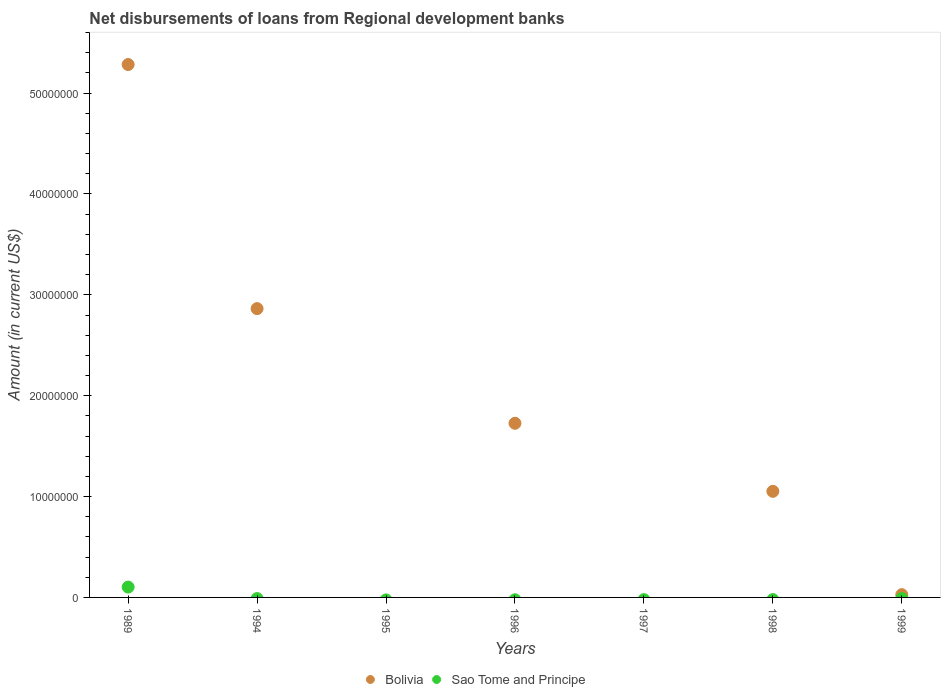How many different coloured dotlines are there?
Make the answer very short. 2. What is the amount of disbursements of loans from regional development banks in Bolivia in 1999?
Ensure brevity in your answer.  2.72e+05. Across all years, what is the maximum amount of disbursements of loans from regional development banks in Sao Tome and Principe?
Offer a terse response. 1.03e+06. Across all years, what is the minimum amount of disbursements of loans from regional development banks in Sao Tome and Principe?
Keep it short and to the point. 0. What is the total amount of disbursements of loans from regional development banks in Sao Tome and Principe in the graph?
Provide a succinct answer. 1.03e+06. What is the difference between the amount of disbursements of loans from regional development banks in Bolivia in 1996 and that in 1998?
Your answer should be compact. 6.75e+06. What is the difference between the amount of disbursements of loans from regional development banks in Bolivia in 1998 and the amount of disbursements of loans from regional development banks in Sao Tome and Principe in 1989?
Ensure brevity in your answer.  9.49e+06. What is the average amount of disbursements of loans from regional development banks in Bolivia per year?
Your response must be concise. 1.56e+07. In the year 1989, what is the difference between the amount of disbursements of loans from regional development banks in Bolivia and amount of disbursements of loans from regional development banks in Sao Tome and Principe?
Offer a terse response. 5.18e+07. What is the ratio of the amount of disbursements of loans from regional development banks in Bolivia in 1996 to that in 1998?
Offer a very short reply. 1.64. Is the amount of disbursements of loans from regional development banks in Bolivia in 1994 less than that in 1998?
Make the answer very short. No. What is the difference between the highest and the second highest amount of disbursements of loans from regional development banks in Bolivia?
Ensure brevity in your answer.  2.42e+07. What is the difference between the highest and the lowest amount of disbursements of loans from regional development banks in Sao Tome and Principe?
Your answer should be very brief. 1.03e+06. Is the sum of the amount of disbursements of loans from regional development banks in Bolivia in 1994 and 1996 greater than the maximum amount of disbursements of loans from regional development banks in Sao Tome and Principe across all years?
Make the answer very short. Yes. Does the amount of disbursements of loans from regional development banks in Bolivia monotonically increase over the years?
Your answer should be very brief. No. Is the amount of disbursements of loans from regional development banks in Sao Tome and Principe strictly less than the amount of disbursements of loans from regional development banks in Bolivia over the years?
Offer a terse response. No. How many dotlines are there?
Make the answer very short. 2. How many years are there in the graph?
Keep it short and to the point. 7. Are the values on the major ticks of Y-axis written in scientific E-notation?
Make the answer very short. No. Does the graph contain any zero values?
Your answer should be compact. Yes. Does the graph contain grids?
Keep it short and to the point. No. Where does the legend appear in the graph?
Ensure brevity in your answer.  Bottom center. How are the legend labels stacked?
Your answer should be very brief. Horizontal. What is the title of the graph?
Your response must be concise. Net disbursements of loans from Regional development banks. Does "Mexico" appear as one of the legend labels in the graph?
Give a very brief answer. No. What is the label or title of the X-axis?
Your response must be concise. Years. What is the label or title of the Y-axis?
Provide a succinct answer. Amount (in current US$). What is the Amount (in current US$) of Bolivia in 1989?
Your answer should be very brief. 5.28e+07. What is the Amount (in current US$) in Sao Tome and Principe in 1989?
Keep it short and to the point. 1.03e+06. What is the Amount (in current US$) in Bolivia in 1994?
Make the answer very short. 2.86e+07. What is the Amount (in current US$) in Bolivia in 1995?
Provide a succinct answer. 0. What is the Amount (in current US$) in Sao Tome and Principe in 1995?
Offer a very short reply. 0. What is the Amount (in current US$) of Bolivia in 1996?
Keep it short and to the point. 1.73e+07. What is the Amount (in current US$) of Sao Tome and Principe in 1996?
Offer a very short reply. 0. What is the Amount (in current US$) in Bolivia in 1997?
Make the answer very short. 0. What is the Amount (in current US$) of Sao Tome and Principe in 1997?
Your answer should be very brief. 0. What is the Amount (in current US$) of Bolivia in 1998?
Give a very brief answer. 1.05e+07. What is the Amount (in current US$) in Sao Tome and Principe in 1998?
Your answer should be very brief. 0. What is the Amount (in current US$) of Bolivia in 1999?
Offer a terse response. 2.72e+05. What is the Amount (in current US$) of Sao Tome and Principe in 1999?
Your answer should be very brief. 0. Across all years, what is the maximum Amount (in current US$) of Bolivia?
Provide a short and direct response. 5.28e+07. Across all years, what is the maximum Amount (in current US$) in Sao Tome and Principe?
Your answer should be compact. 1.03e+06. Across all years, what is the minimum Amount (in current US$) in Bolivia?
Make the answer very short. 0. What is the total Amount (in current US$) of Bolivia in the graph?
Offer a very short reply. 1.10e+08. What is the total Amount (in current US$) in Sao Tome and Principe in the graph?
Keep it short and to the point. 1.03e+06. What is the difference between the Amount (in current US$) in Bolivia in 1989 and that in 1994?
Your response must be concise. 2.42e+07. What is the difference between the Amount (in current US$) of Bolivia in 1989 and that in 1996?
Your response must be concise. 3.56e+07. What is the difference between the Amount (in current US$) in Bolivia in 1989 and that in 1998?
Offer a terse response. 4.23e+07. What is the difference between the Amount (in current US$) of Bolivia in 1989 and that in 1999?
Your answer should be compact. 5.26e+07. What is the difference between the Amount (in current US$) of Bolivia in 1994 and that in 1996?
Provide a short and direct response. 1.14e+07. What is the difference between the Amount (in current US$) in Bolivia in 1994 and that in 1998?
Offer a terse response. 1.81e+07. What is the difference between the Amount (in current US$) of Bolivia in 1994 and that in 1999?
Offer a terse response. 2.84e+07. What is the difference between the Amount (in current US$) in Bolivia in 1996 and that in 1998?
Your response must be concise. 6.75e+06. What is the difference between the Amount (in current US$) in Bolivia in 1996 and that in 1999?
Your response must be concise. 1.70e+07. What is the difference between the Amount (in current US$) in Bolivia in 1998 and that in 1999?
Provide a succinct answer. 1.02e+07. What is the average Amount (in current US$) of Bolivia per year?
Provide a succinct answer. 1.56e+07. What is the average Amount (in current US$) in Sao Tome and Principe per year?
Keep it short and to the point. 1.47e+05. In the year 1989, what is the difference between the Amount (in current US$) in Bolivia and Amount (in current US$) in Sao Tome and Principe?
Give a very brief answer. 5.18e+07. What is the ratio of the Amount (in current US$) of Bolivia in 1989 to that in 1994?
Give a very brief answer. 1.85. What is the ratio of the Amount (in current US$) of Bolivia in 1989 to that in 1996?
Your response must be concise. 3.06. What is the ratio of the Amount (in current US$) in Bolivia in 1989 to that in 1998?
Provide a short and direct response. 5.02. What is the ratio of the Amount (in current US$) of Bolivia in 1989 to that in 1999?
Your response must be concise. 194.24. What is the ratio of the Amount (in current US$) of Bolivia in 1994 to that in 1996?
Keep it short and to the point. 1.66. What is the ratio of the Amount (in current US$) in Bolivia in 1994 to that in 1998?
Your response must be concise. 2.72. What is the ratio of the Amount (in current US$) of Bolivia in 1994 to that in 1999?
Your answer should be compact. 105.27. What is the ratio of the Amount (in current US$) in Bolivia in 1996 to that in 1998?
Ensure brevity in your answer.  1.64. What is the ratio of the Amount (in current US$) of Bolivia in 1996 to that in 1999?
Offer a very short reply. 63.47. What is the ratio of the Amount (in current US$) in Bolivia in 1998 to that in 1999?
Make the answer very short. 38.67. What is the difference between the highest and the second highest Amount (in current US$) of Bolivia?
Provide a succinct answer. 2.42e+07. What is the difference between the highest and the lowest Amount (in current US$) in Bolivia?
Your answer should be very brief. 5.28e+07. What is the difference between the highest and the lowest Amount (in current US$) of Sao Tome and Principe?
Ensure brevity in your answer.  1.03e+06. 